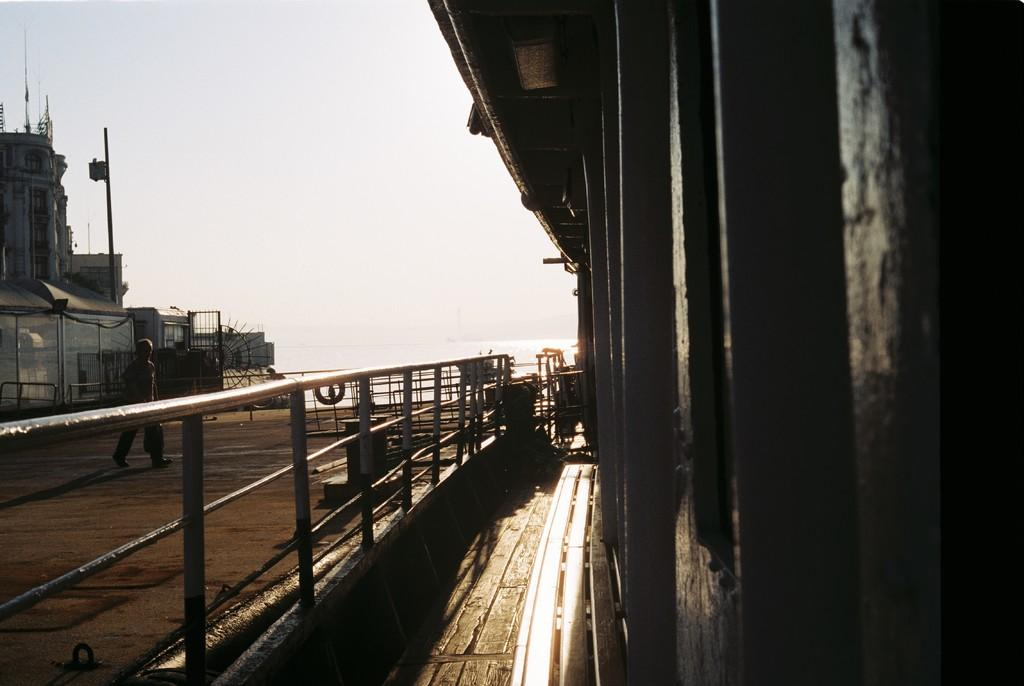What is the main subject of the picture? The main subject of the picture is a ship. What type of environment is the ship situated in? There is water visible in the background of the picture, suggesting that the ship is in a maritime environment. What type of business is being conducted on the ship in the image? There is no indication in the image of any business being conducted on the ship. What type of coil can be seen on the ship in the image? There is no coil visible on the ship in the image. 